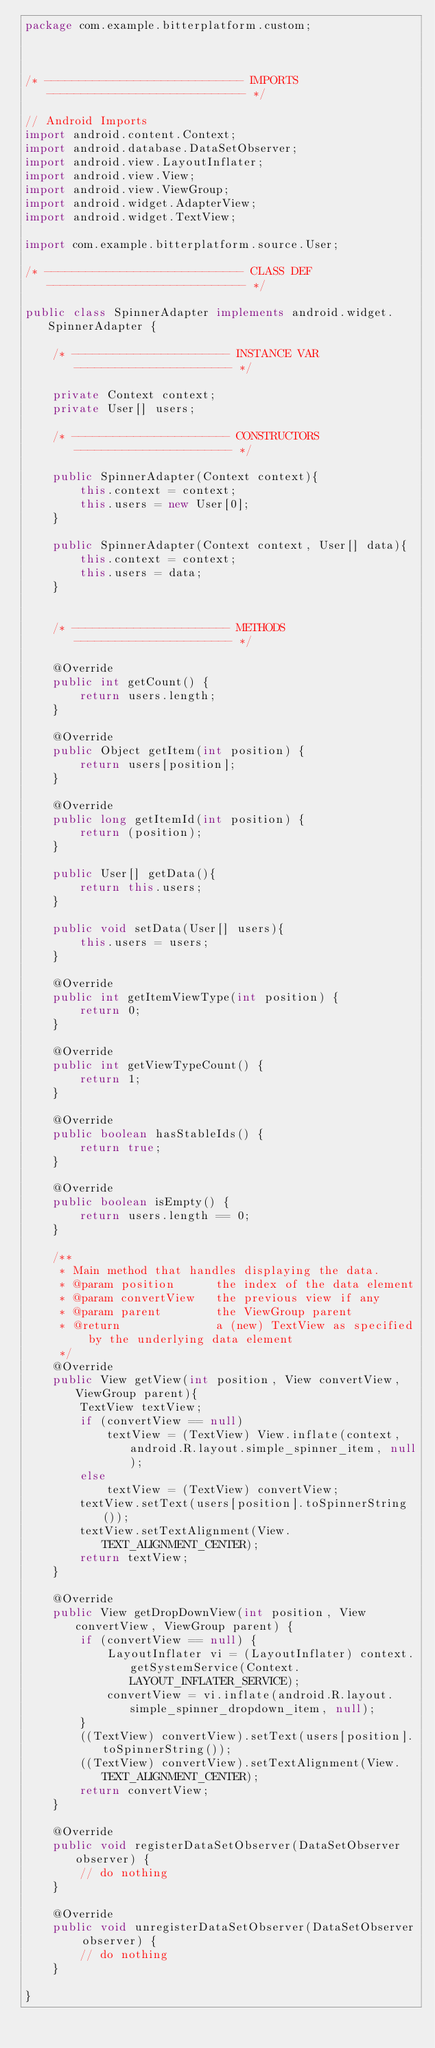Convert code to text. <code><loc_0><loc_0><loc_500><loc_500><_Java_>package com.example.bitterplatform.custom;



/* ----------------------------- IMPORTS ----------------------------- */

// Android Imports
import android.content.Context;
import android.database.DataSetObserver;
import android.view.LayoutInflater;
import android.view.View;
import android.view.ViewGroup;
import android.widget.AdapterView;
import android.widget.TextView;

import com.example.bitterplatform.source.User;

/* ----------------------------- CLASS DEF ----------------------------- */

public class SpinnerAdapter implements android.widget.SpinnerAdapter {

    /* ----------------------- INSTANCE VAR ----------------------- */

    private Context context;
    private User[] users;

    /* ----------------------- CONSTRUCTORS ----------------------- */

    public SpinnerAdapter(Context context){
        this.context = context;
        this.users = new User[0];
    }

    public SpinnerAdapter(Context context, User[] data){
        this.context = context;
        this.users = data;
    }


    /* ----------------------- METHODS ----------------------- */

    @Override
    public int getCount() {
        return users.length;
    }

    @Override
    public Object getItem(int position) {
        return users[position];
    }

    @Override
    public long getItemId(int position) {
        return (position);
    }

    public User[] getData(){
        return this.users;
    }

    public void setData(User[] users){
        this.users = users;
    }

    @Override
    public int getItemViewType(int position) {
        return 0;
    }

    @Override
    public int getViewTypeCount() {
        return 1;
    }

    @Override
    public boolean hasStableIds() {
        return true;
    }

    @Override
    public boolean isEmpty() {
        return users.length == 0;
    }

    /**
     * Main method that handles displaying the data.
     * @param position      the index of the data element
     * @param convertView   the previous view if any
     * @param parent        the ViewGroup parent
     * @return              a (new) TextView as specified by the underlying data element
     */
    @Override
    public View getView(int position, View convertView, ViewGroup parent){
        TextView textView;
        if (convertView == null)
            textView = (TextView) View.inflate(context, android.R.layout.simple_spinner_item, null);
        else
            textView = (TextView) convertView;
        textView.setText(users[position].toSpinnerString());
        textView.setTextAlignment(View.TEXT_ALIGNMENT_CENTER);
        return textView;
    }

    @Override
    public View getDropDownView(int position, View convertView, ViewGroup parent) {
        if (convertView == null) {
            LayoutInflater vi = (LayoutInflater) context.getSystemService(Context.LAYOUT_INFLATER_SERVICE);
            convertView = vi.inflate(android.R.layout.simple_spinner_dropdown_item, null);
        }
        ((TextView) convertView).setText(users[position].toSpinnerString());
        ((TextView) convertView).setTextAlignment(View.TEXT_ALIGNMENT_CENTER);
        return convertView;
    }

    @Override
    public void registerDataSetObserver(DataSetObserver observer) {
        // do nothing
    }

    @Override
    public void unregisterDataSetObserver(DataSetObserver observer) {
        // do nothing
    }

}
</code> 